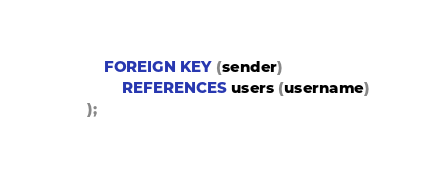Convert code to text. <code><loc_0><loc_0><loc_500><loc_500><_SQL_>	FOREIGN KEY (sender)
		REFERENCES users (username)
);</code> 